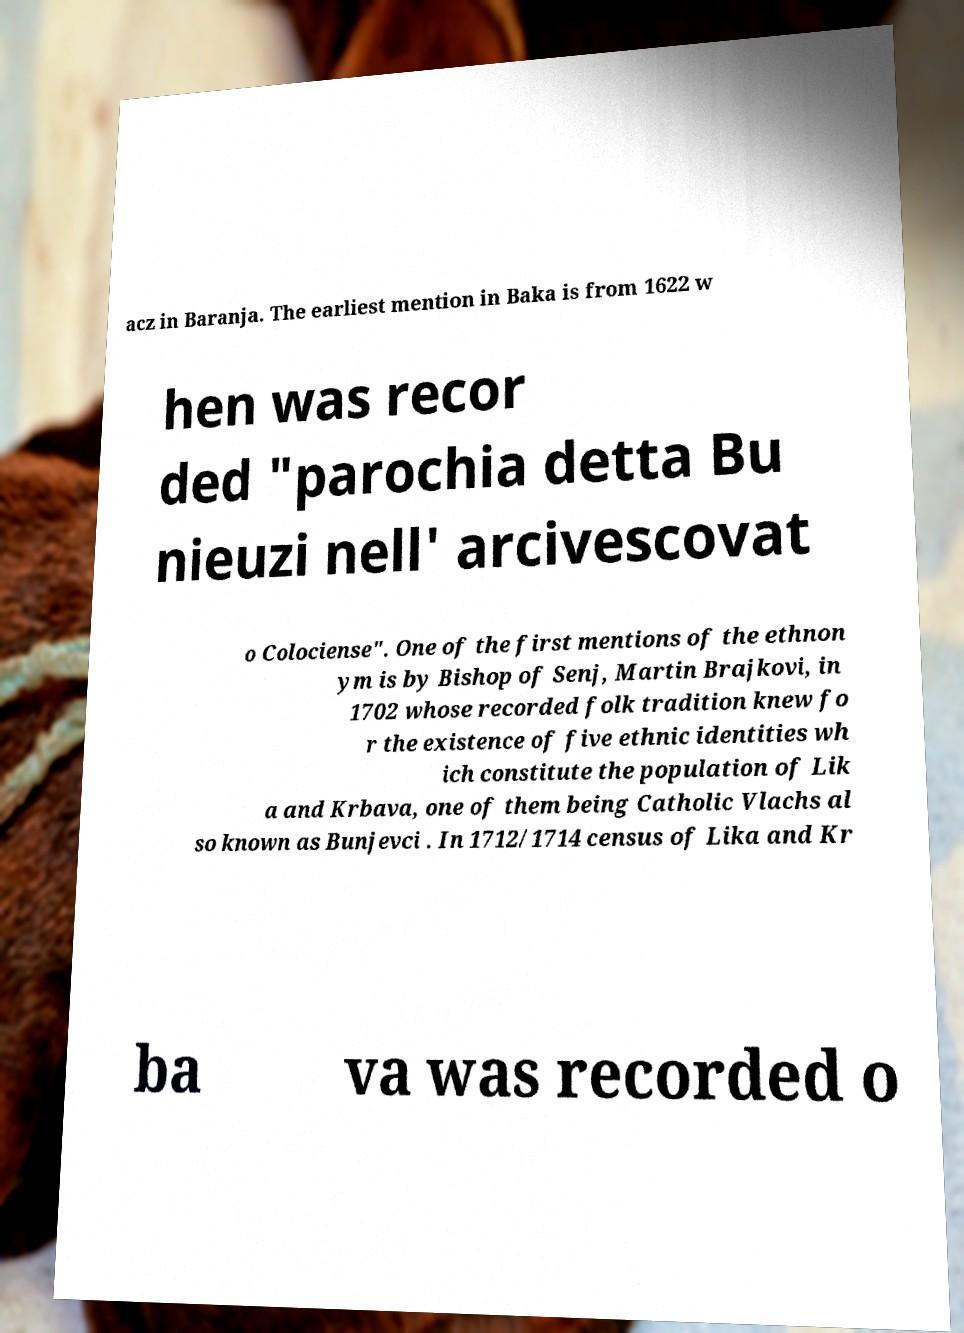For documentation purposes, I need the text within this image transcribed. Could you provide that? acz in Baranja. The earliest mention in Baka is from 1622 w hen was recor ded "parochia detta Bu nieuzi nell' arcivescovat o Colociense". One of the first mentions of the ethnon ym is by Bishop of Senj, Martin Brajkovi, in 1702 whose recorded folk tradition knew fo r the existence of five ethnic identities wh ich constitute the population of Lik a and Krbava, one of them being Catholic Vlachs al so known as Bunjevci . In 1712/1714 census of Lika and Kr ba va was recorded o 